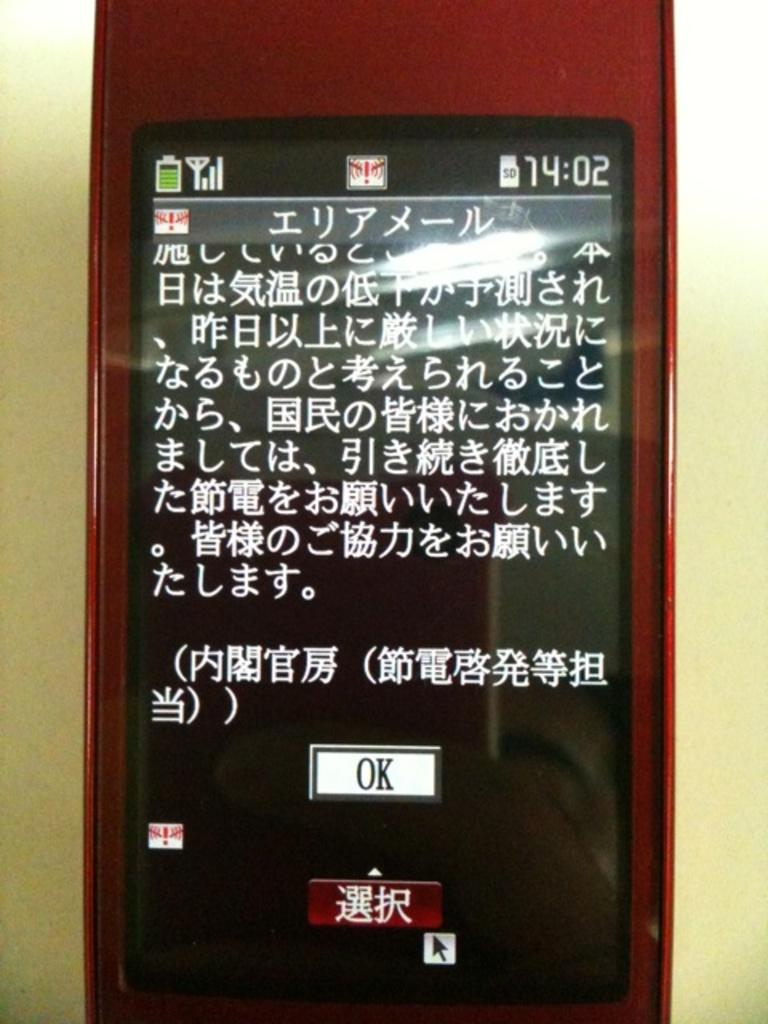<image>
Describe the image concisely. Press OK to accept whatever agreement is written in this Asian text. 